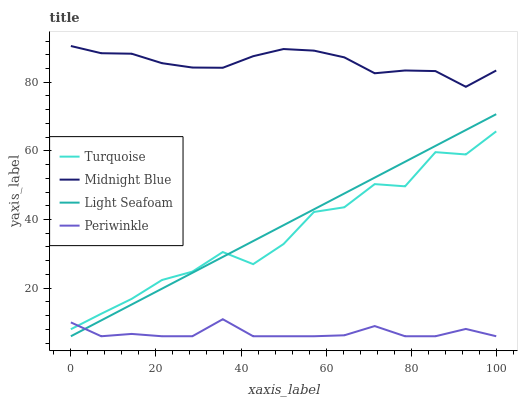Does Light Seafoam have the minimum area under the curve?
Answer yes or no. No. Does Light Seafoam have the maximum area under the curve?
Answer yes or no. No. Is Periwinkle the smoothest?
Answer yes or no. No. Is Periwinkle the roughest?
Answer yes or no. No. Does Midnight Blue have the lowest value?
Answer yes or no. No. Does Light Seafoam have the highest value?
Answer yes or no. No. Is Periwinkle less than Midnight Blue?
Answer yes or no. Yes. Is Midnight Blue greater than Light Seafoam?
Answer yes or no. Yes. Does Periwinkle intersect Midnight Blue?
Answer yes or no. No. 